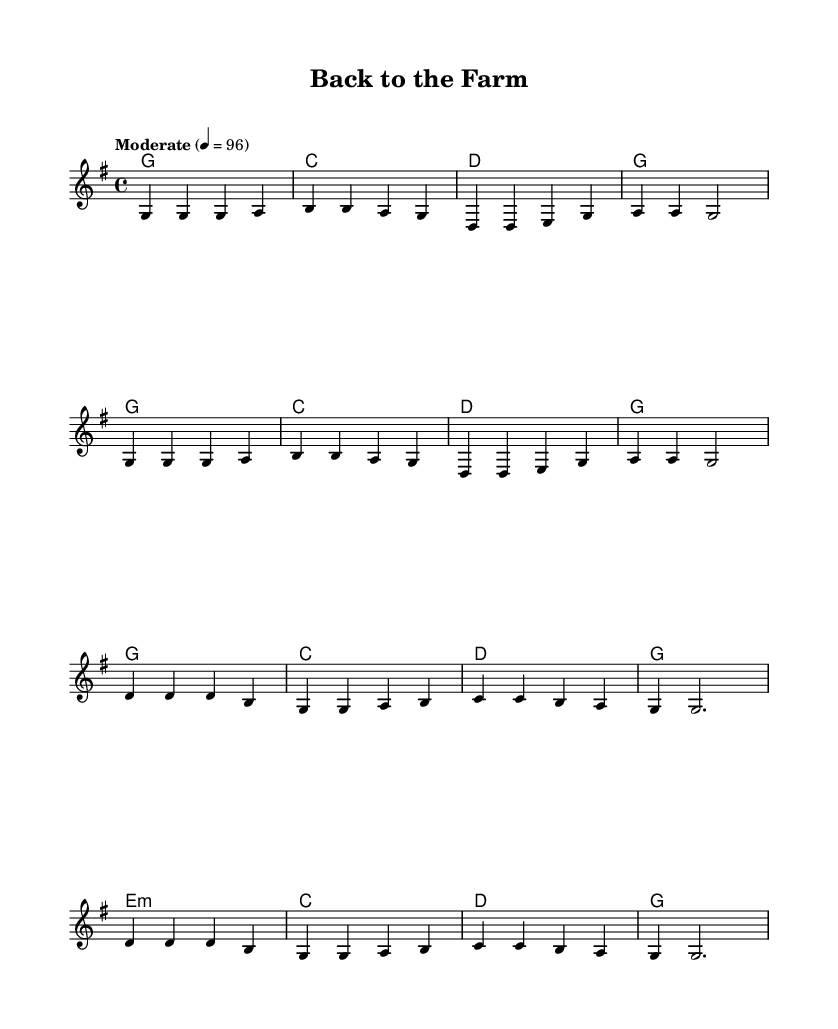What is the key signature of this music? The key signature is G major, which has one sharp (F#). This can be determined by looking at the key signature indicated at the beginning of the piece.
Answer: G major What is the time signature of the piece? The time signature is 4/4, as indicated at the beginning of the score. This means there are four beats in each measure and the quarter note receives one beat.
Answer: 4/4 What is the tempo marking for this music? The tempo marking is "Moderate," with a metronome indication of 4 = 96. This tells the performer to play at a moderate speed with a quarter note equating to 96 beats per minute.
Answer: Moderate How many measures are in the verse? The verse consists of 8 measures, which can be counted from the notation shown before the chorus begins. Each group of notes is contained within a measure marked by vertical lines.
Answer: 8 measures What type of chords are primarily used in the chorus? The primary chords used in the chorus are G, C, and D. These are typical chords found in many country songs that convey a sense of familiarity and nostalgia.
Answer: G, C, D What lyrical theme is reflected in the song? The lyrical theme reflects nostalgia for simpler times on a farm, contrasting past experiences with current life. This can be determined by analyzing the words of the verse and chorus provided in the sheet music.
Answer: Nostalgia for simpler times What is the structure of the song? The song follows a verse-chorus structure, starting with the verse and moving into the chorus, which is a common format in country music, allowing for storytelling followed by a memorable refrain.
Answer: Verse-chorus structure 